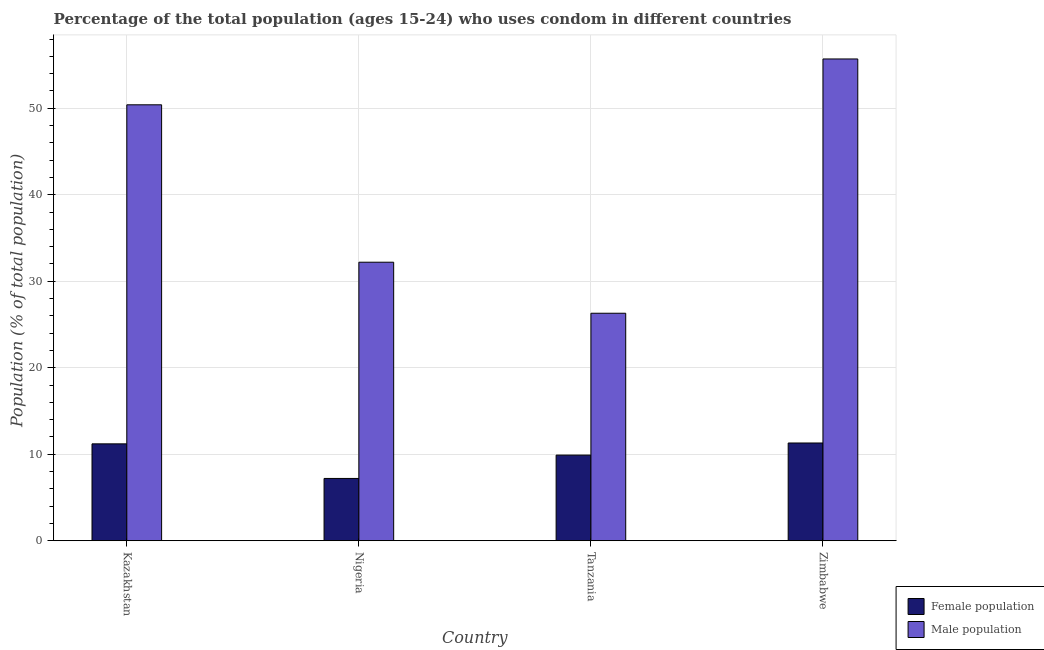How many different coloured bars are there?
Your response must be concise. 2. How many groups of bars are there?
Offer a very short reply. 4. How many bars are there on the 2nd tick from the left?
Ensure brevity in your answer.  2. How many bars are there on the 2nd tick from the right?
Your answer should be very brief. 2. What is the label of the 4th group of bars from the left?
Make the answer very short. Zimbabwe. What is the male population in Nigeria?
Keep it short and to the point. 32.2. Across all countries, what is the maximum male population?
Give a very brief answer. 55.7. Across all countries, what is the minimum male population?
Keep it short and to the point. 26.3. In which country was the male population maximum?
Your answer should be very brief. Zimbabwe. In which country was the female population minimum?
Keep it short and to the point. Nigeria. What is the total male population in the graph?
Keep it short and to the point. 164.6. What is the difference between the female population in Kazakhstan and that in Nigeria?
Your response must be concise. 4. What is the difference between the male population in Kazakhstan and the female population in Tanzania?
Give a very brief answer. 40.5. What is the average female population per country?
Keep it short and to the point. 9.9. What is the difference between the female population and male population in Tanzania?
Keep it short and to the point. -16.4. What is the ratio of the male population in Nigeria to that in Zimbabwe?
Your response must be concise. 0.58. What is the difference between the highest and the second highest female population?
Your response must be concise. 0.1. What is the difference between the highest and the lowest male population?
Provide a succinct answer. 29.4. In how many countries, is the male population greater than the average male population taken over all countries?
Your response must be concise. 2. What does the 1st bar from the left in Tanzania represents?
Your answer should be compact. Female population. What does the 1st bar from the right in Tanzania represents?
Your response must be concise. Male population. How many bars are there?
Your response must be concise. 8. How many countries are there in the graph?
Keep it short and to the point. 4. What is the difference between two consecutive major ticks on the Y-axis?
Your answer should be very brief. 10. Where does the legend appear in the graph?
Provide a succinct answer. Bottom right. How many legend labels are there?
Provide a short and direct response. 2. What is the title of the graph?
Your answer should be very brief. Percentage of the total population (ages 15-24) who uses condom in different countries. What is the label or title of the X-axis?
Your response must be concise. Country. What is the label or title of the Y-axis?
Provide a short and direct response. Population (% of total population) . What is the Population (% of total population)  in Male population in Kazakhstan?
Your response must be concise. 50.4. What is the Population (% of total population)  of Female population in Nigeria?
Your answer should be very brief. 7.2. What is the Population (% of total population)  in Male population in Nigeria?
Provide a short and direct response. 32.2. What is the Population (% of total population)  of Female population in Tanzania?
Make the answer very short. 9.9. What is the Population (% of total population)  in Male population in Tanzania?
Give a very brief answer. 26.3. What is the Population (% of total population)  of Female population in Zimbabwe?
Make the answer very short. 11.3. What is the Population (% of total population)  in Male population in Zimbabwe?
Your answer should be very brief. 55.7. Across all countries, what is the maximum Population (% of total population)  of Male population?
Give a very brief answer. 55.7. Across all countries, what is the minimum Population (% of total population)  of Female population?
Your response must be concise. 7.2. Across all countries, what is the minimum Population (% of total population)  of Male population?
Make the answer very short. 26.3. What is the total Population (% of total population)  of Female population in the graph?
Keep it short and to the point. 39.6. What is the total Population (% of total population)  of Male population in the graph?
Your response must be concise. 164.6. What is the difference between the Population (% of total population)  of Female population in Kazakhstan and that in Nigeria?
Your response must be concise. 4. What is the difference between the Population (% of total population)  of Male population in Kazakhstan and that in Tanzania?
Make the answer very short. 24.1. What is the difference between the Population (% of total population)  in Male population in Nigeria and that in Tanzania?
Keep it short and to the point. 5.9. What is the difference between the Population (% of total population)  of Female population in Nigeria and that in Zimbabwe?
Provide a succinct answer. -4.1. What is the difference between the Population (% of total population)  in Male population in Nigeria and that in Zimbabwe?
Your response must be concise. -23.5. What is the difference between the Population (% of total population)  of Female population in Tanzania and that in Zimbabwe?
Your answer should be very brief. -1.4. What is the difference between the Population (% of total population)  in Male population in Tanzania and that in Zimbabwe?
Your response must be concise. -29.4. What is the difference between the Population (% of total population)  in Female population in Kazakhstan and the Population (% of total population)  in Male population in Nigeria?
Your answer should be very brief. -21. What is the difference between the Population (% of total population)  of Female population in Kazakhstan and the Population (% of total population)  of Male population in Tanzania?
Offer a very short reply. -15.1. What is the difference between the Population (% of total population)  of Female population in Kazakhstan and the Population (% of total population)  of Male population in Zimbabwe?
Offer a very short reply. -44.5. What is the difference between the Population (% of total population)  in Female population in Nigeria and the Population (% of total population)  in Male population in Tanzania?
Provide a succinct answer. -19.1. What is the difference between the Population (% of total population)  of Female population in Nigeria and the Population (% of total population)  of Male population in Zimbabwe?
Provide a short and direct response. -48.5. What is the difference between the Population (% of total population)  of Female population in Tanzania and the Population (% of total population)  of Male population in Zimbabwe?
Your answer should be very brief. -45.8. What is the average Population (% of total population)  in Male population per country?
Offer a terse response. 41.15. What is the difference between the Population (% of total population)  in Female population and Population (% of total population)  in Male population in Kazakhstan?
Give a very brief answer. -39.2. What is the difference between the Population (% of total population)  of Female population and Population (% of total population)  of Male population in Nigeria?
Offer a very short reply. -25. What is the difference between the Population (% of total population)  in Female population and Population (% of total population)  in Male population in Tanzania?
Offer a terse response. -16.4. What is the difference between the Population (% of total population)  in Female population and Population (% of total population)  in Male population in Zimbabwe?
Offer a very short reply. -44.4. What is the ratio of the Population (% of total population)  in Female population in Kazakhstan to that in Nigeria?
Make the answer very short. 1.56. What is the ratio of the Population (% of total population)  in Male population in Kazakhstan to that in Nigeria?
Keep it short and to the point. 1.57. What is the ratio of the Population (% of total population)  of Female population in Kazakhstan to that in Tanzania?
Make the answer very short. 1.13. What is the ratio of the Population (% of total population)  in Male population in Kazakhstan to that in Tanzania?
Your answer should be very brief. 1.92. What is the ratio of the Population (% of total population)  of Male population in Kazakhstan to that in Zimbabwe?
Give a very brief answer. 0.9. What is the ratio of the Population (% of total population)  of Female population in Nigeria to that in Tanzania?
Give a very brief answer. 0.73. What is the ratio of the Population (% of total population)  of Male population in Nigeria to that in Tanzania?
Give a very brief answer. 1.22. What is the ratio of the Population (% of total population)  in Female population in Nigeria to that in Zimbabwe?
Make the answer very short. 0.64. What is the ratio of the Population (% of total population)  in Male population in Nigeria to that in Zimbabwe?
Your answer should be very brief. 0.58. What is the ratio of the Population (% of total population)  in Female population in Tanzania to that in Zimbabwe?
Provide a succinct answer. 0.88. What is the ratio of the Population (% of total population)  of Male population in Tanzania to that in Zimbabwe?
Your answer should be compact. 0.47. What is the difference between the highest and the second highest Population (% of total population)  of Male population?
Ensure brevity in your answer.  5.3. What is the difference between the highest and the lowest Population (% of total population)  of Male population?
Keep it short and to the point. 29.4. 